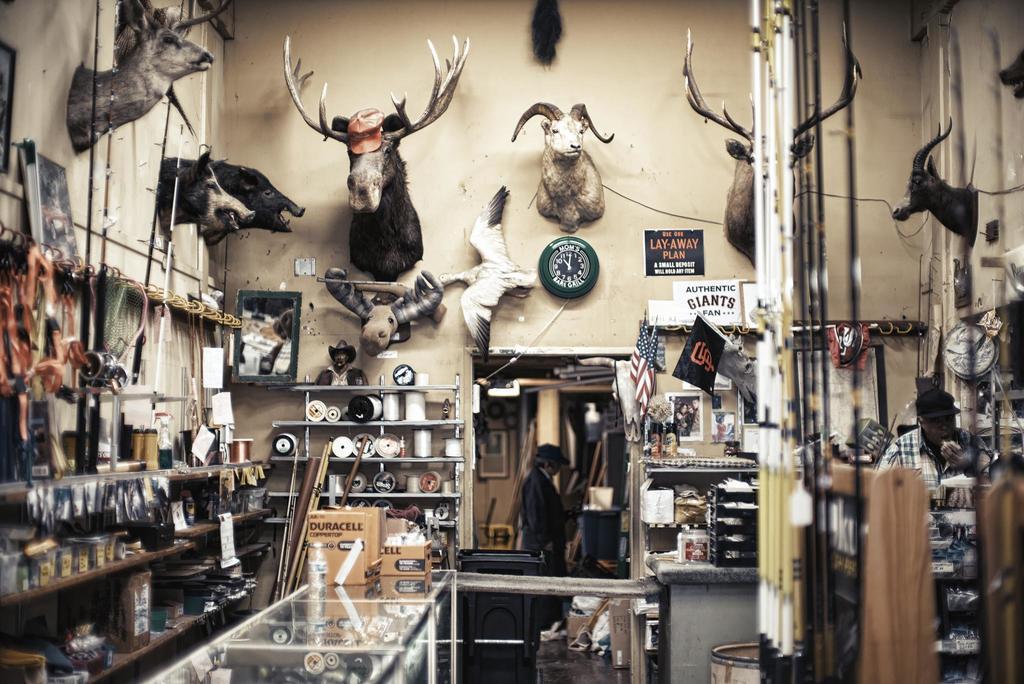Do they accept "layaway" plans?
Give a very brief answer. Yes. 